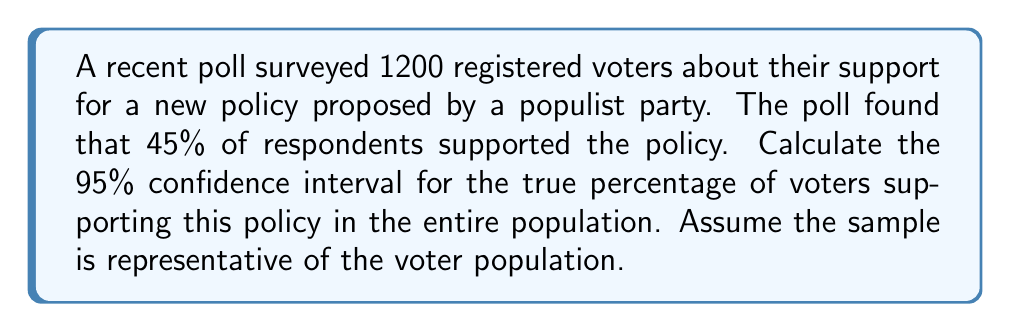Solve this math problem. To calculate the confidence interval, we'll use the formula for a large sample proportion:

$$ \hat{p} \pm z_{\alpha/2} \sqrt{\frac{\hat{p}(1-\hat{p})}{n}} $$

Where:
- $\hat{p}$ is the sample proportion
- $z_{\alpha/2}$ is the critical value for the desired confidence level
- $n$ is the sample size

Steps:
1) $\hat{p} = 0.45$ (45% expressed as a decimal)
2) $n = 1200$
3) For a 95% confidence interval, $z_{\alpha/2} = 1.96$

4) Calculate the standard error:
   $$ SE = \sqrt{\frac{\hat{p}(1-\hat{p})}{n}} = \sqrt{\frac{0.45(1-0.45)}{1200}} = 0.0144 $$

5) Calculate the margin of error:
   $$ ME = z_{\alpha/2} \cdot SE = 1.96 \cdot 0.0144 = 0.0282 $$

6) Calculate the confidence interval:
   $$ 0.45 \pm 0.0282 $$
   $$ (0.4218, 0.4782) $$

7) Convert to percentages:
   $$ (42.18\%, 47.82\%) $$

This means we can be 95% confident that the true proportion of voters supporting the policy in the entire population is between 42.18% and 47.82%.
Answer: The 95% confidence interval for the percentage of voters supporting the policy is (42.18%, 47.82%). 